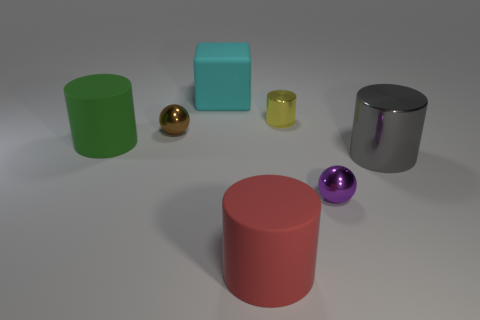Add 3 green balls. How many objects exist? 10 Subtract all gray metallic cylinders. How many cylinders are left? 3 Subtract all cyan things. Subtract all big blocks. How many objects are left? 5 Add 5 big gray metallic objects. How many big gray metallic objects are left? 6 Add 5 big red spheres. How many big red spheres exist? 5 Subtract all purple spheres. How many spheres are left? 1 Subtract 1 cyan blocks. How many objects are left? 6 Subtract all balls. How many objects are left? 5 Subtract 1 blocks. How many blocks are left? 0 Subtract all green blocks. Subtract all cyan cylinders. How many blocks are left? 1 